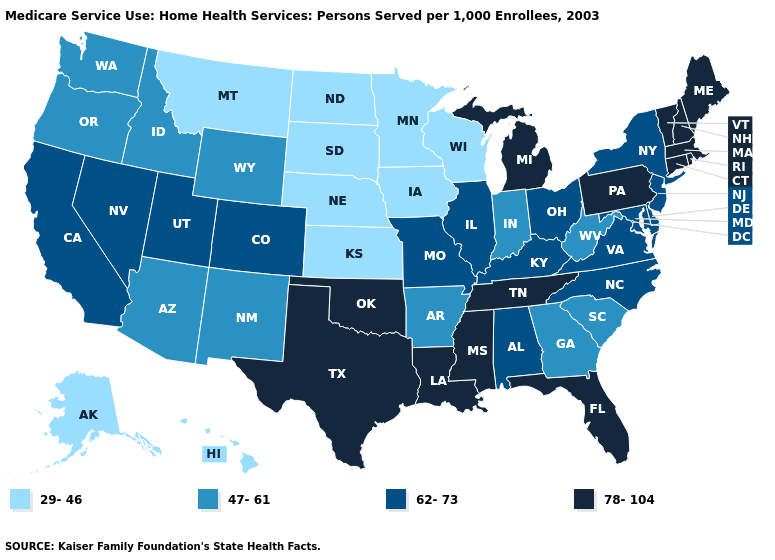Is the legend a continuous bar?
Short answer required. No. Does the first symbol in the legend represent the smallest category?
Write a very short answer. Yes. Name the states that have a value in the range 29-46?
Keep it brief. Alaska, Hawaii, Iowa, Kansas, Minnesota, Montana, Nebraska, North Dakota, South Dakota, Wisconsin. Name the states that have a value in the range 47-61?
Short answer required. Arizona, Arkansas, Georgia, Idaho, Indiana, New Mexico, Oregon, South Carolina, Washington, West Virginia, Wyoming. Which states have the highest value in the USA?
Quick response, please. Connecticut, Florida, Louisiana, Maine, Massachusetts, Michigan, Mississippi, New Hampshire, Oklahoma, Pennsylvania, Rhode Island, Tennessee, Texas, Vermont. Does Idaho have the highest value in the West?
Write a very short answer. No. Does Montana have the lowest value in the West?
Short answer required. Yes. What is the lowest value in the Northeast?
Short answer required. 62-73. Among the states that border Kansas , which have the highest value?
Be succinct. Oklahoma. Among the states that border North Carolina , which have the highest value?
Short answer required. Tennessee. Among the states that border Missouri , which have the highest value?
Concise answer only. Oklahoma, Tennessee. Name the states that have a value in the range 47-61?
Give a very brief answer. Arizona, Arkansas, Georgia, Idaho, Indiana, New Mexico, Oregon, South Carolina, Washington, West Virginia, Wyoming. Does Michigan have a lower value than Wyoming?
Quick response, please. No. Name the states that have a value in the range 78-104?
Short answer required. Connecticut, Florida, Louisiana, Maine, Massachusetts, Michigan, Mississippi, New Hampshire, Oklahoma, Pennsylvania, Rhode Island, Tennessee, Texas, Vermont. Name the states that have a value in the range 78-104?
Keep it brief. Connecticut, Florida, Louisiana, Maine, Massachusetts, Michigan, Mississippi, New Hampshire, Oklahoma, Pennsylvania, Rhode Island, Tennessee, Texas, Vermont. 